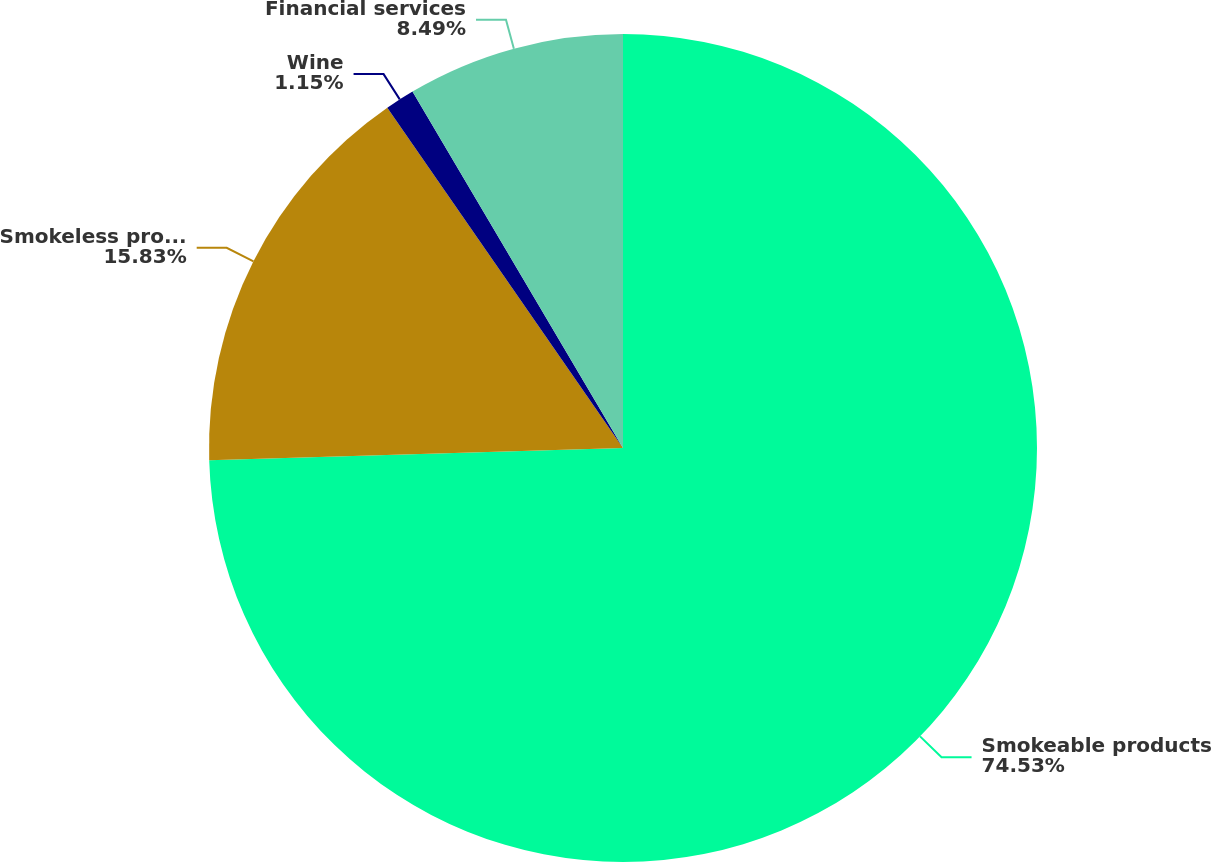<chart> <loc_0><loc_0><loc_500><loc_500><pie_chart><fcel>Smokeable products<fcel>Smokeless products<fcel>Wine<fcel>Financial services<nl><fcel>74.53%<fcel>15.83%<fcel>1.15%<fcel>8.49%<nl></chart> 